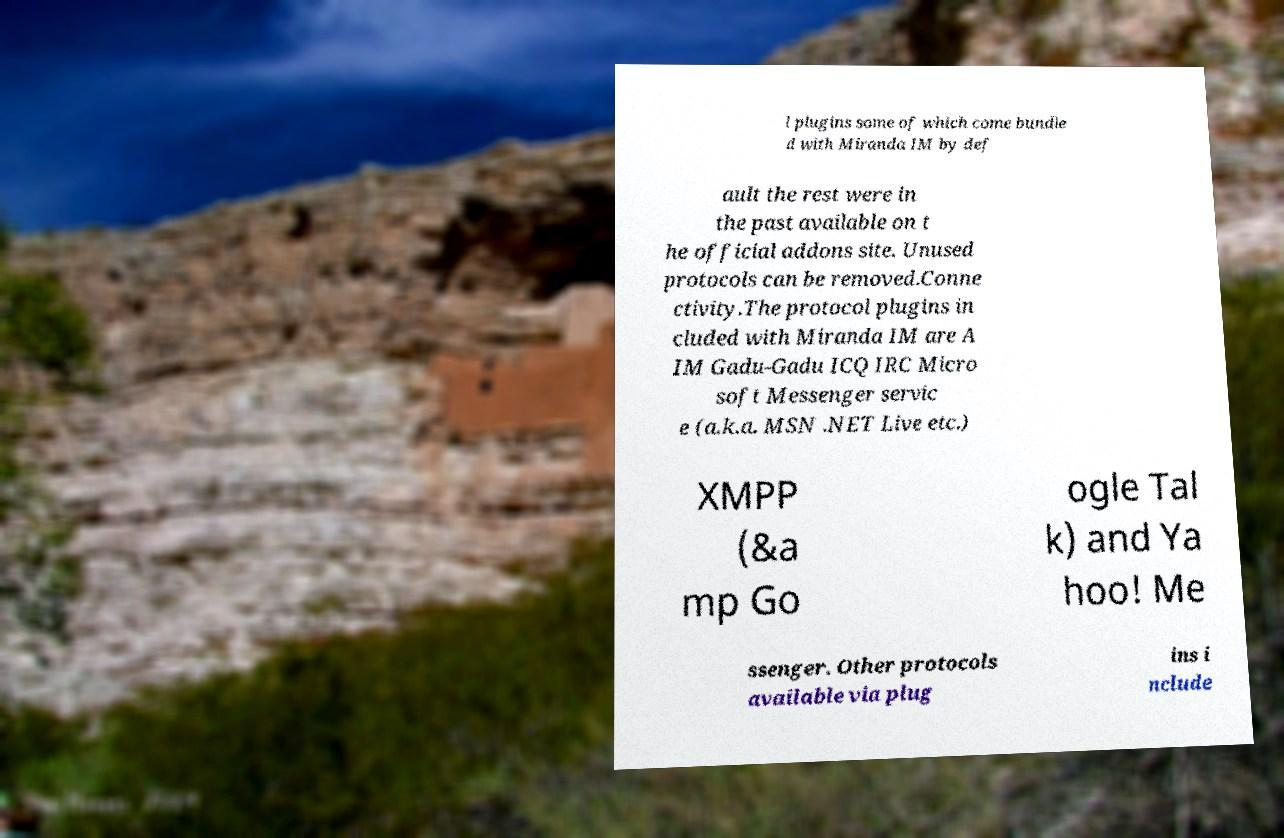What messages or text are displayed in this image? I need them in a readable, typed format. l plugins some of which come bundle d with Miranda IM by def ault the rest were in the past available on t he official addons site. Unused protocols can be removed.Conne ctivity.The protocol plugins in cluded with Miranda IM are A IM Gadu-Gadu ICQ IRC Micro soft Messenger servic e (a.k.a. MSN .NET Live etc.) XMPP (&a mp Go ogle Tal k) and Ya hoo! Me ssenger. Other protocols available via plug ins i nclude 